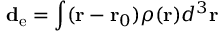<formula> <loc_0><loc_0><loc_500><loc_500>d _ { e } = \int ( { r } - { r } _ { 0 } ) \rho ( { r } ) d ^ { 3 } { r }</formula> 